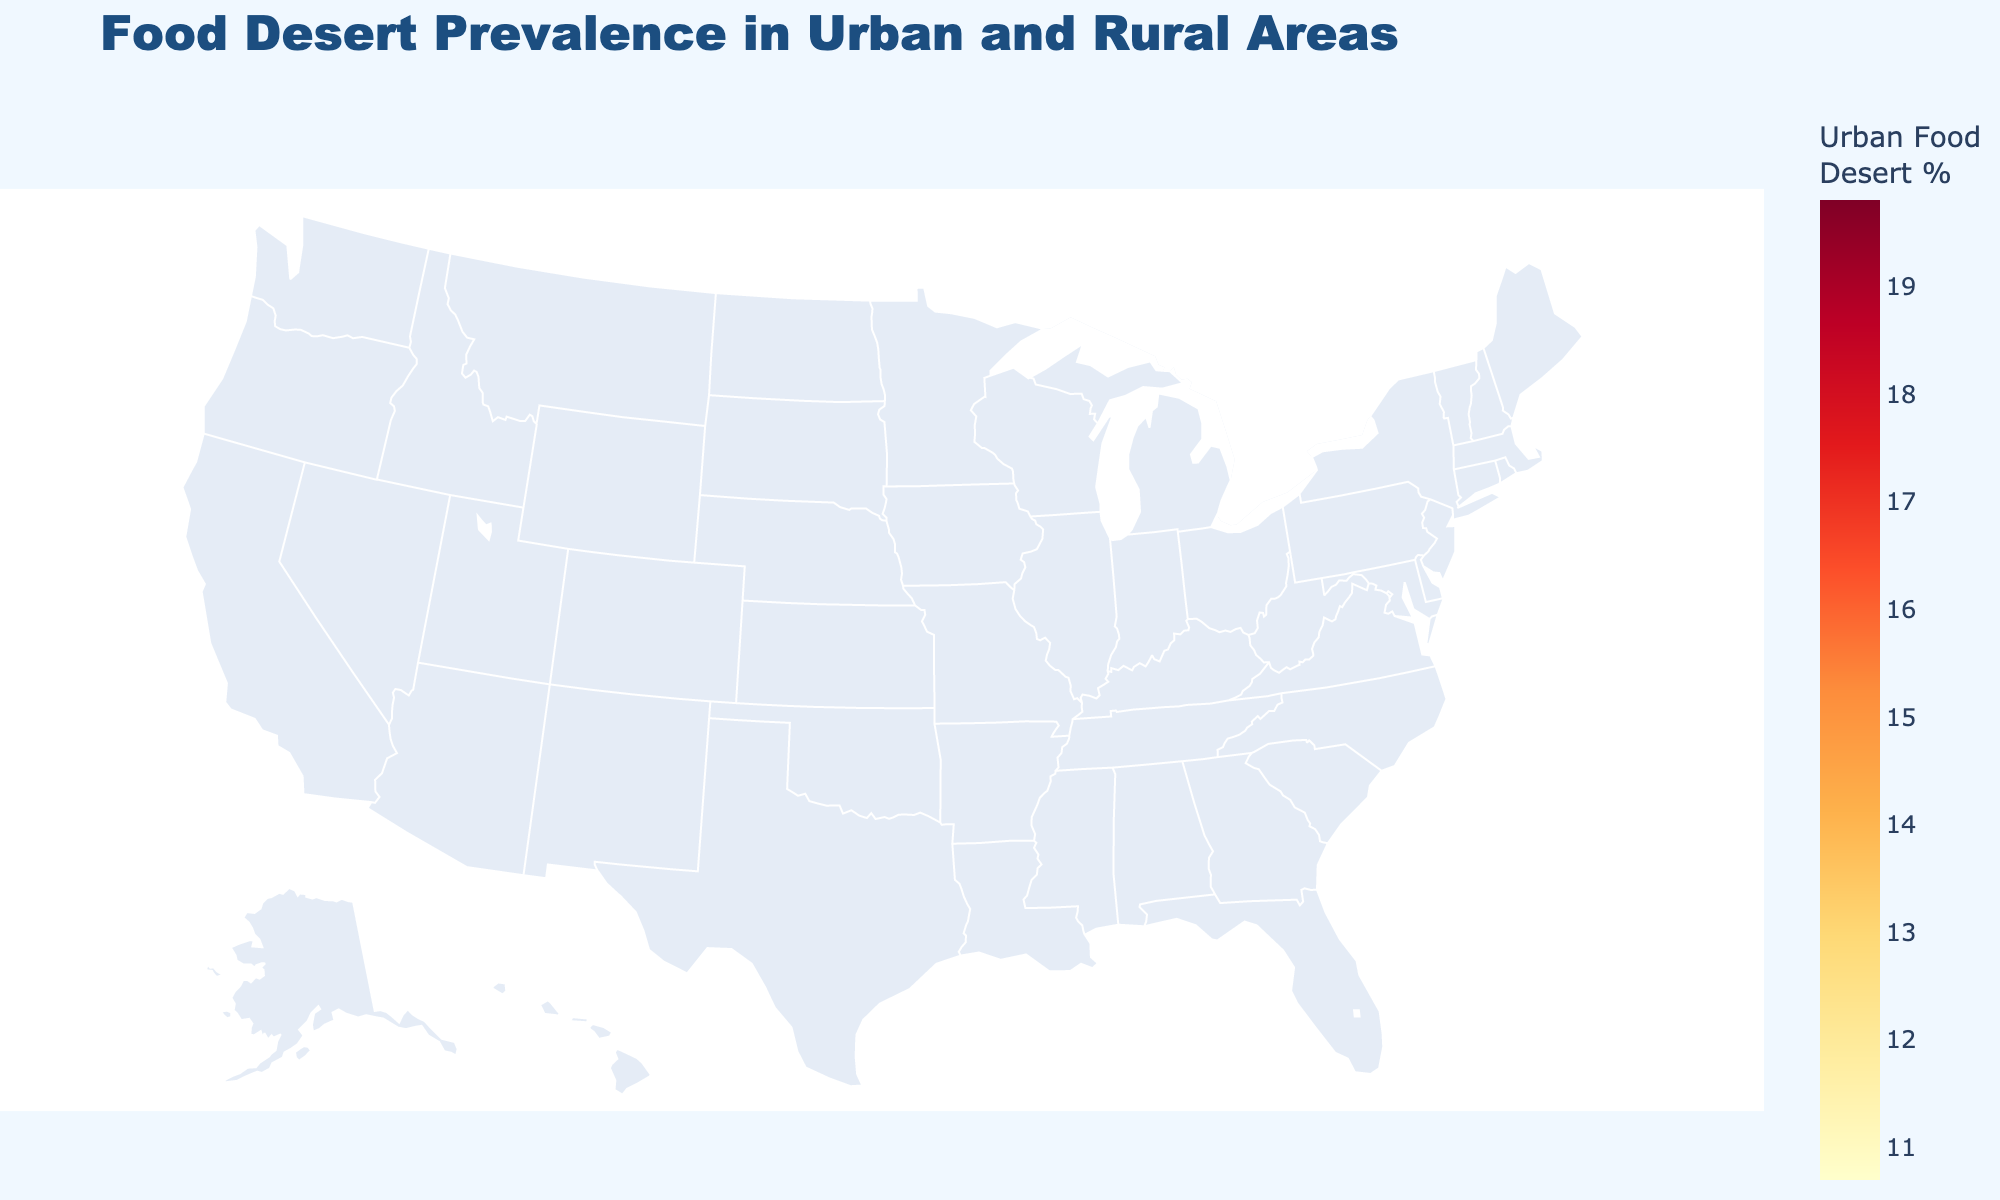Which state has the highest urban food desert percentage? Observe the figure and find the state with the darkest shade of red, which represents the highest urban food desert percentage.
Answer: Alabama What is the difference in rural food desert percentages between Ohio and Alabama? First, identify the rural food desert percentages for Ohio (9.8%) and Alabama (14.2%) in the figure. Then, subtract Ohio's percentage from Alabama's.
Answer: 4.4% Which state shows the lowest rural food desert percentage? Look for the state with the lightest color shade in rural food desert percentages.
Answer: California Compare the urban food desert percentages of Illinois and Tennessee. Which state has a higher percentage? Find the urban food desert percentages for Illinois (16.2%) and Tennessee (18.5%) in the figure, then determine which is higher.
Answer: Tennessee What is the average urban food desert percentage for California, Texas, and New York? Locate the urban food desert percentages for California (12.8%), Texas (15.6%), and New York (14.2%). Add them up and divide by 3 to get the average.
Answer: 14.2% Is the urban food desert percentage in Georgia greater than the rural food desert percentage in Florida? Identify Georgia's urban food desert percentage (18.1%) and Florida's rural food desert percentage (8.1%) and compare them.
Answer: Yes What can be inferred about the general trend of food desert percentages between urban and rural areas? Observe the color differences between urban and rural areas across various states. Generally, urban areas have higher percentages of food deserts compared to rural areas.
Answer: Urban areas generally have higher percentages In which state does the percentage of urban food deserts most closely match the percentage of rural food deserts? Compare both percentages for each state. North Carolina has urban (15.7%) and rural (12.3%), making the closest match between values among the states provided.
Answer: North Carolina 